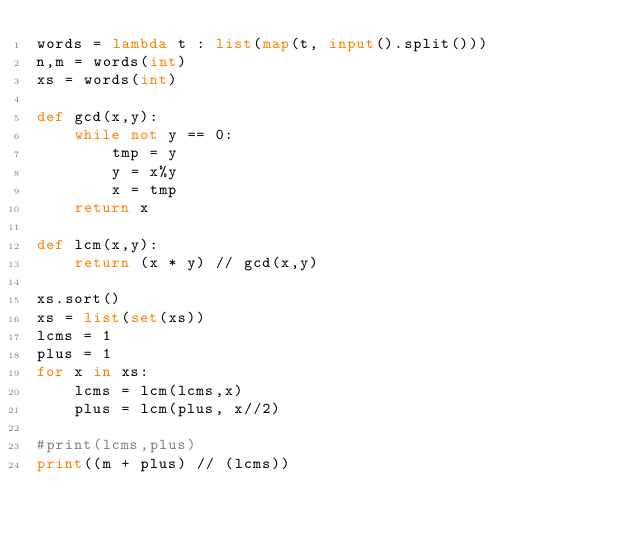Convert code to text. <code><loc_0><loc_0><loc_500><loc_500><_Python_>words = lambda t : list(map(t, input().split()))
n,m = words(int)
xs = words(int)

def gcd(x,y):
    while not y == 0:
        tmp = y
        y = x%y
        x = tmp
    return x

def lcm(x,y):
    return (x * y) // gcd(x,y)

xs.sort()
xs = list(set(xs))
lcms = 1
plus = 1
for x in xs:
    lcms = lcm(lcms,x)
    plus = lcm(plus, x//2)

#print(lcms,plus)
print((m + plus) // (lcms))
</code> 